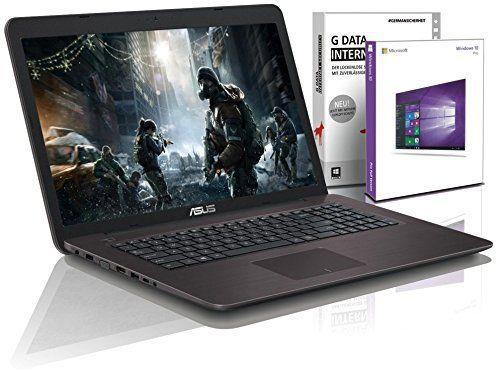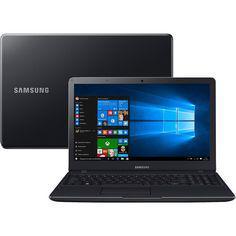The first image is the image on the left, the second image is the image on the right. Considering the images on both sides, is "At least one computer has a blue graphic background on the screen." valid? Answer yes or no. Yes. 